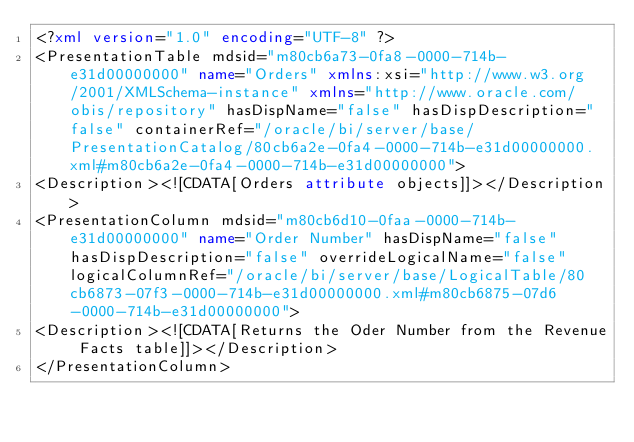<code> <loc_0><loc_0><loc_500><loc_500><_XML_><?xml version="1.0" encoding="UTF-8" ?>
<PresentationTable mdsid="m80cb6a73-0fa8-0000-714b-e31d00000000" name="Orders" xmlns:xsi="http://www.w3.org/2001/XMLSchema-instance" xmlns="http://www.oracle.com/obis/repository" hasDispName="false" hasDispDescription="false" containerRef="/oracle/bi/server/base/PresentationCatalog/80cb6a2e-0fa4-0000-714b-e31d00000000.xml#m80cb6a2e-0fa4-0000-714b-e31d00000000">
<Description><![CDATA[Orders attribute objects]]></Description>
<PresentationColumn mdsid="m80cb6d10-0faa-0000-714b-e31d00000000" name="Order Number" hasDispName="false" hasDispDescription="false" overrideLogicalName="false" logicalColumnRef="/oracle/bi/server/base/LogicalTable/80cb6873-07f3-0000-714b-e31d00000000.xml#m80cb6875-07d6-0000-714b-e31d00000000">
<Description><![CDATA[Returns the Oder Number from the Revenue Facts table]]></Description>
</PresentationColumn></code> 